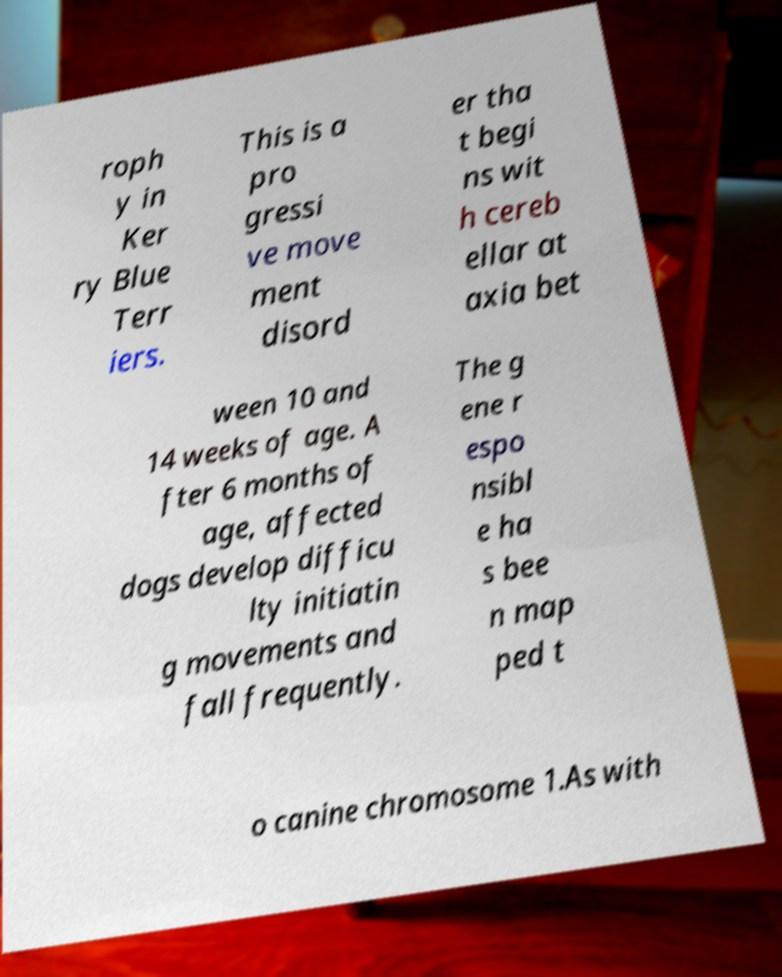Could you extract and type out the text from this image? roph y in Ker ry Blue Terr iers. This is a pro gressi ve move ment disord er tha t begi ns wit h cereb ellar at axia bet ween 10 and 14 weeks of age. A fter 6 months of age, affected dogs develop difficu lty initiatin g movements and fall frequently. The g ene r espo nsibl e ha s bee n map ped t o canine chromosome 1.As with 